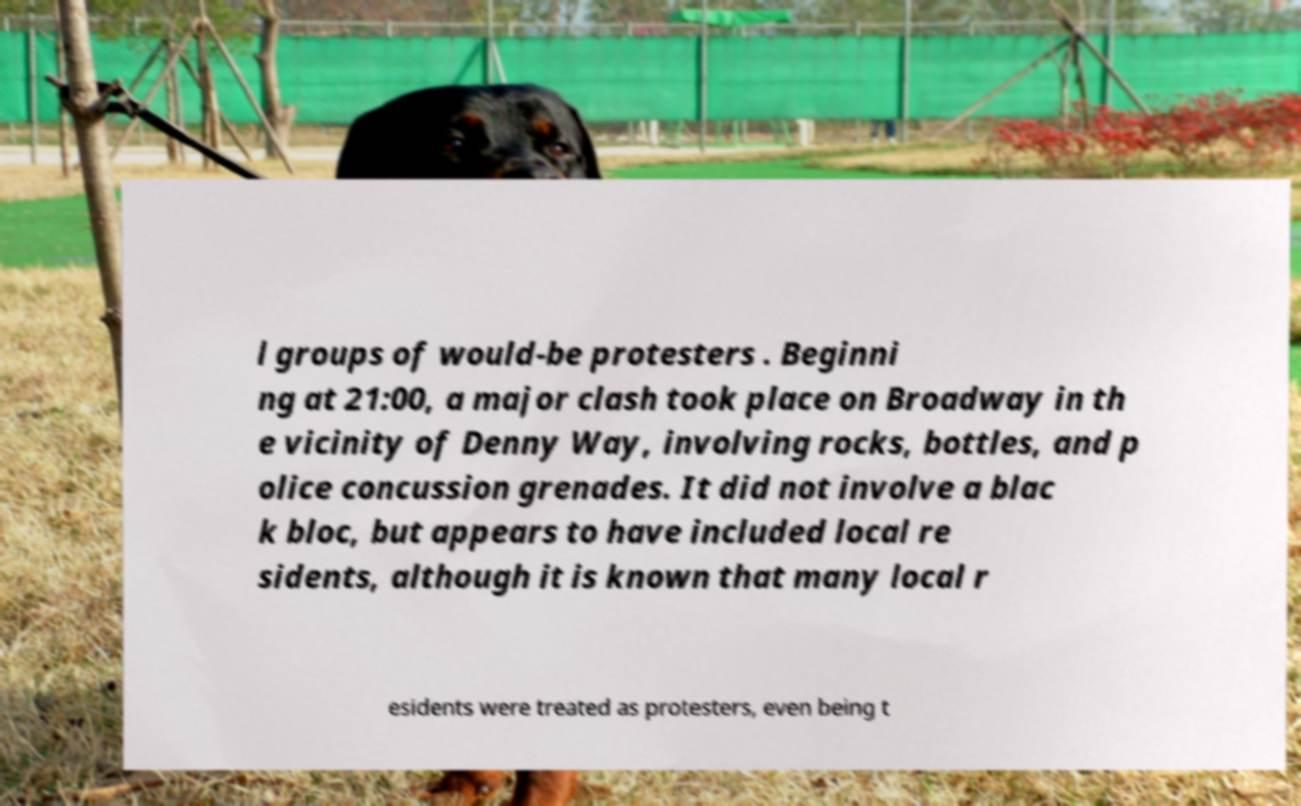Can you accurately transcribe the text from the provided image for me? l groups of would-be protesters . Beginni ng at 21:00, a major clash took place on Broadway in th e vicinity of Denny Way, involving rocks, bottles, and p olice concussion grenades. It did not involve a blac k bloc, but appears to have included local re sidents, although it is known that many local r esidents were treated as protesters, even being t 